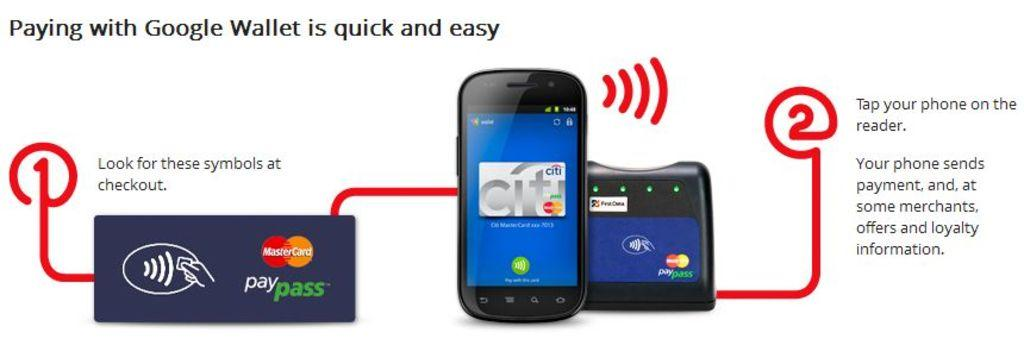<image>
Present a compact description of the photo's key features. A diagram showing how to pay with Google Wallet linking phones with credit cards. 